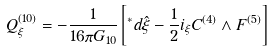<formula> <loc_0><loc_0><loc_500><loc_500>Q ^ { ( 1 0 ) } _ { \xi } = - \frac { 1 } { 1 6 \pi G _ { 1 0 } } \left [ ^ { * } d \hat { \xi } - \frac { 1 } { 2 } i _ { \xi } C ^ { ( 4 ) } \wedge F ^ { ( 5 ) } \right ]</formula> 